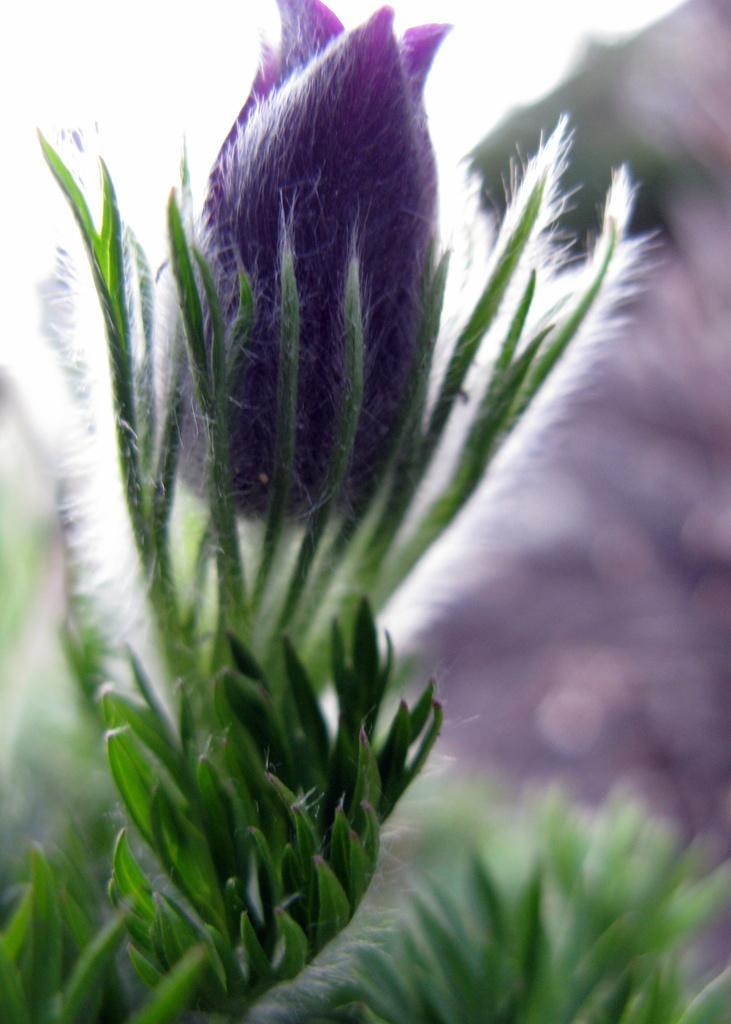Could you give a brief overview of what you see in this image? In this picture I can see there is a grass, some plant and it has a bud. 